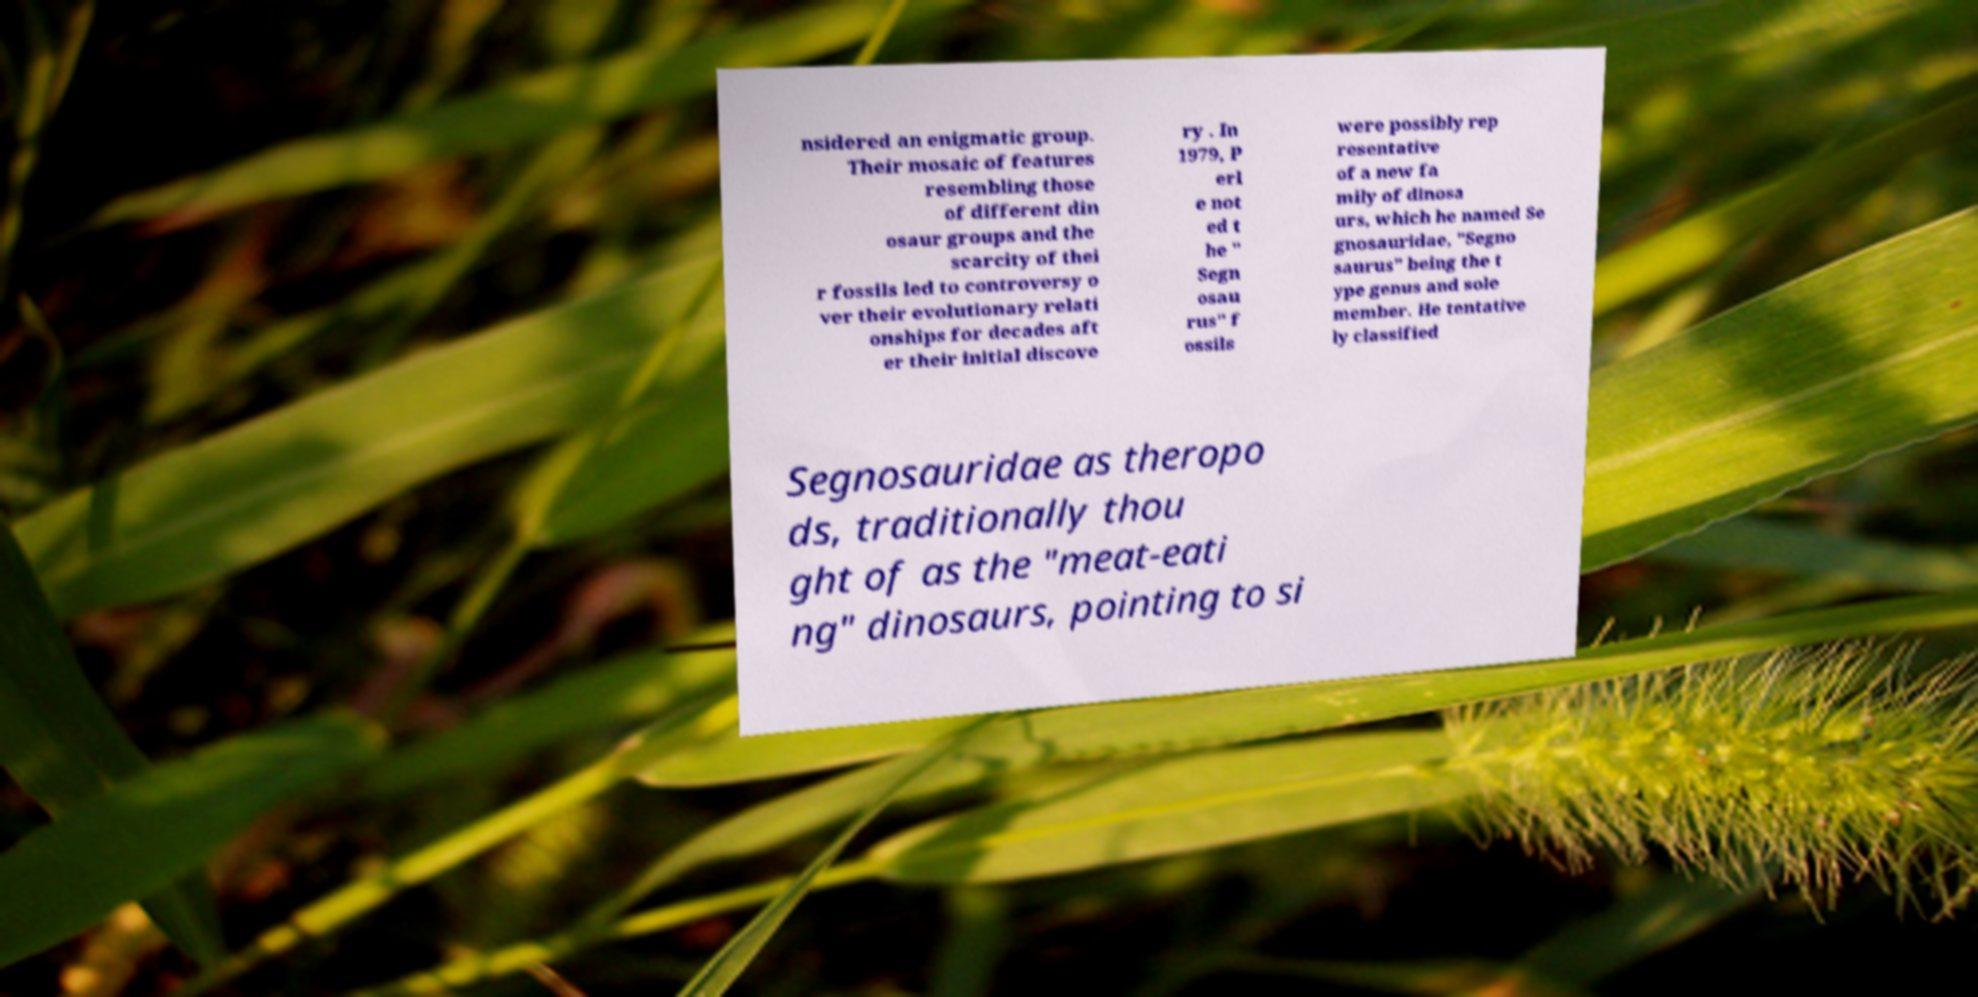For documentation purposes, I need the text within this image transcribed. Could you provide that? nsidered an enigmatic group. Their mosaic of features resembling those of different din osaur groups and the scarcity of thei r fossils led to controversy o ver their evolutionary relati onships for decades aft er their initial discove ry . In 1979, P erl e not ed t he " Segn osau rus" f ossils were possibly rep resentative of a new fa mily of dinosa urs, which he named Se gnosauridae, "Segno saurus" being the t ype genus and sole member. He tentative ly classified Segnosauridae as theropo ds, traditionally thou ght of as the "meat-eati ng" dinosaurs, pointing to si 